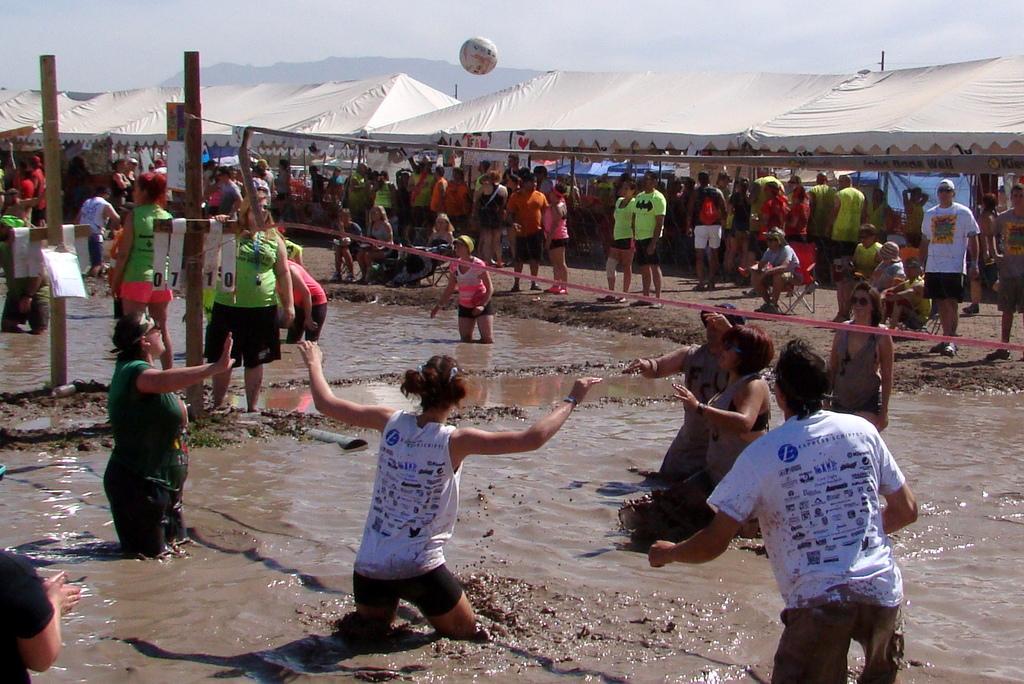Describe this image in one or two sentences. In this picture there are people on the water and some are standing on the floor, they are playing and there are bamboos on the left side of the image, there are stalls in the background area of the image. 